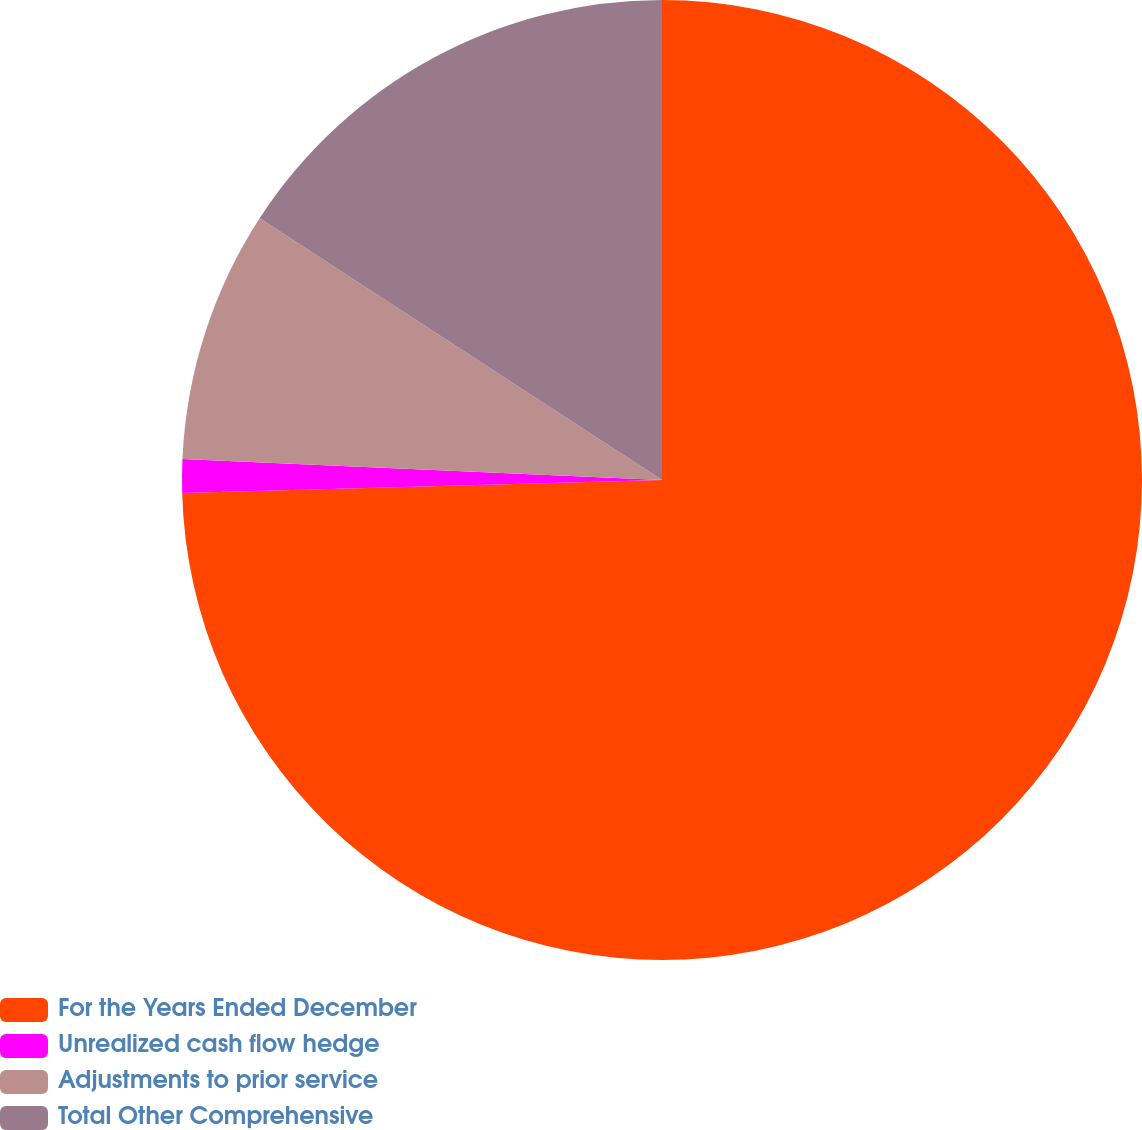<chart> <loc_0><loc_0><loc_500><loc_500><pie_chart><fcel>For the Years Ended December<fcel>Unrealized cash flow hedge<fcel>Adjustments to prior service<fcel>Total Other Comprehensive<nl><fcel>74.57%<fcel>1.13%<fcel>8.48%<fcel>15.82%<nl></chart> 